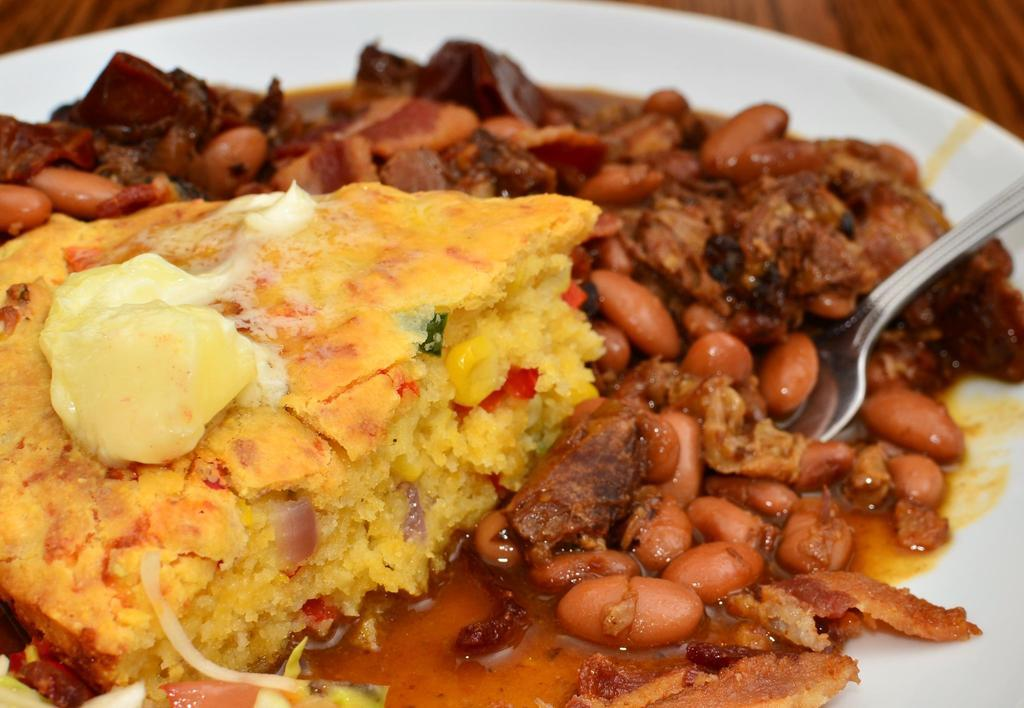What is on the plate in the image? There is a food item on a plate in the image. What utensil is present in the image? There is a spoon in the image. What type of table is visible in the image? There is a wooden table in the image. What type of tank is visible in the image? There is no tank present in the image. What type of laborer is shown working on the wooden table in the image? There is no laborer present in the image; it only shows a food item, a spoon, and a wooden table. 